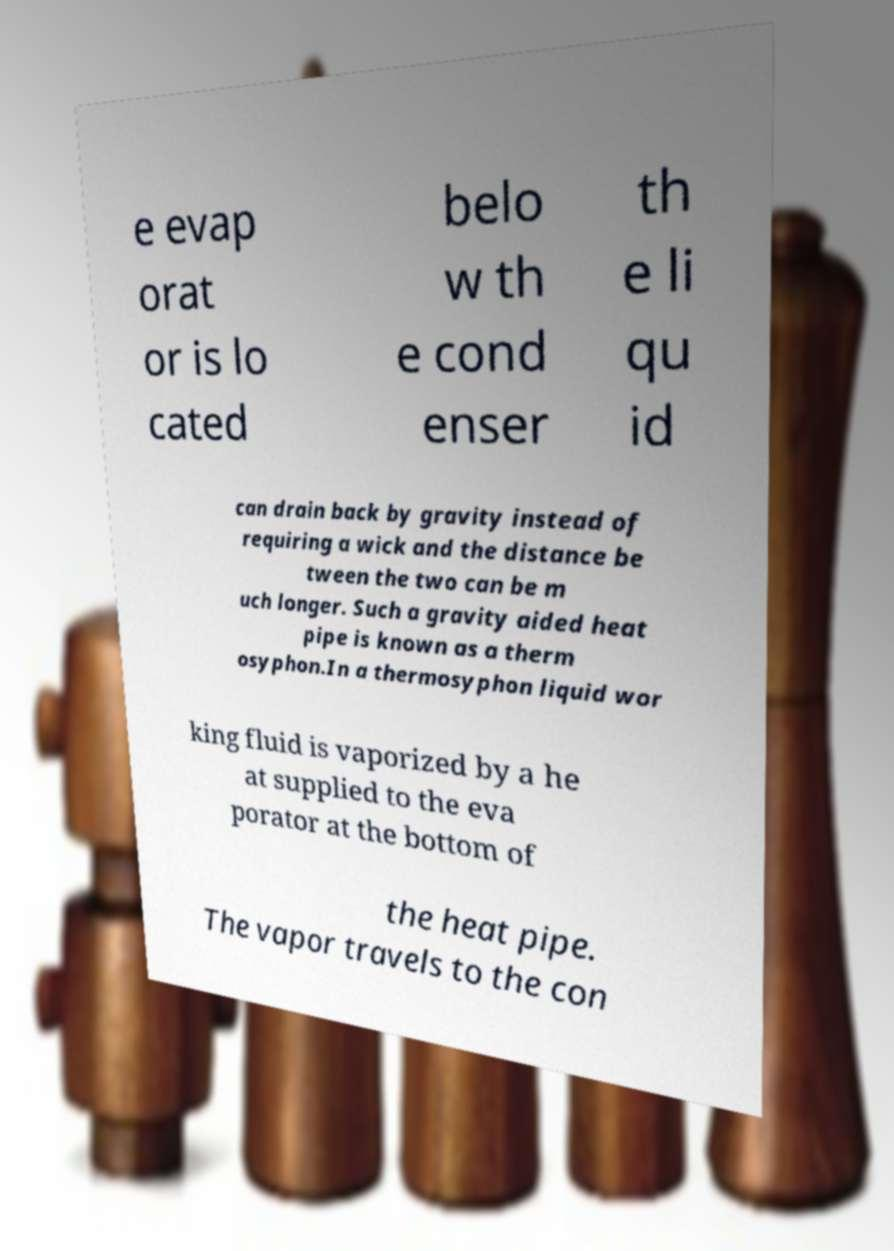There's text embedded in this image that I need extracted. Can you transcribe it verbatim? e evap orat or is lo cated belo w th e cond enser th e li qu id can drain back by gravity instead of requiring a wick and the distance be tween the two can be m uch longer. Such a gravity aided heat pipe is known as a therm osyphon.In a thermosyphon liquid wor king fluid is vaporized by a he at supplied to the eva porator at the bottom of the heat pipe. The vapor travels to the con 